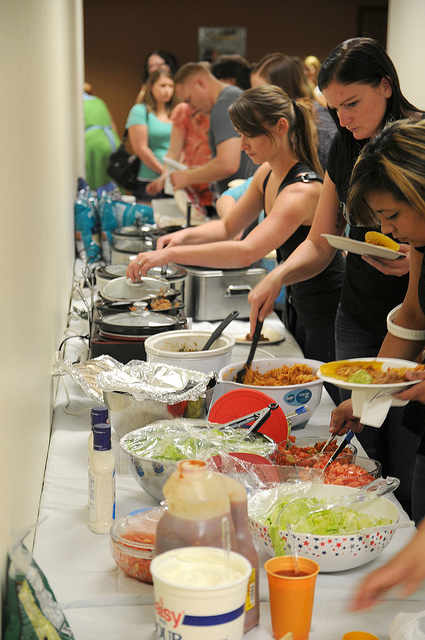<image>What organization are these members of? It is ambiguous what organization these members are a part of, as they could be part of a company, church group, family, or a workgroup. What size is the food? I am not sure what the size of the food is. It could be small, medium, or large. What organization are these members of? I don't know what organization these members are part of. It can be PTA, soup kitchen, PETA, company, nurses, workgroup, family, or church group. What size is the food? I don't know what size the food is. It can be medium, small, or large. 